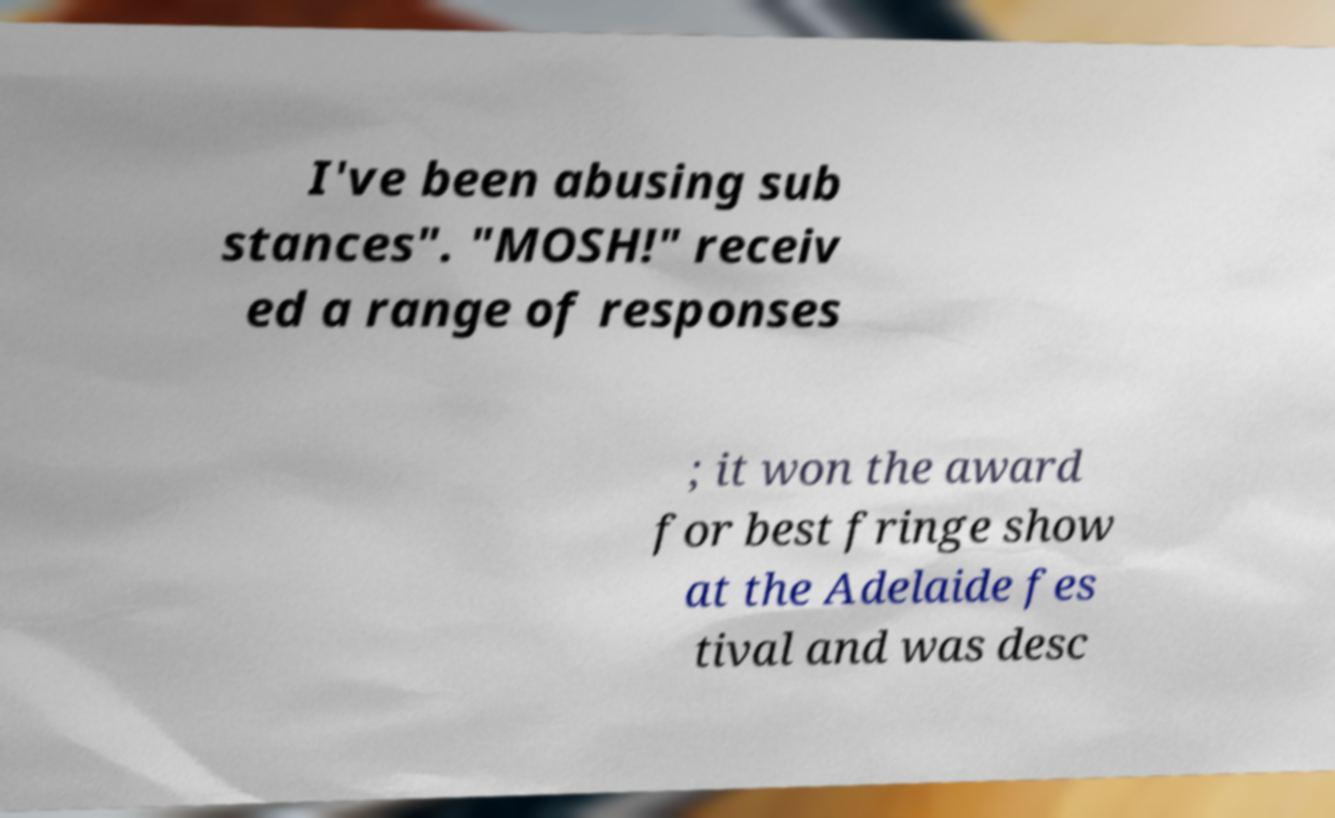What messages or text are displayed in this image? I need them in a readable, typed format. I've been abusing sub stances". "MOSH!" receiv ed a range of responses ; it won the award for best fringe show at the Adelaide fes tival and was desc 